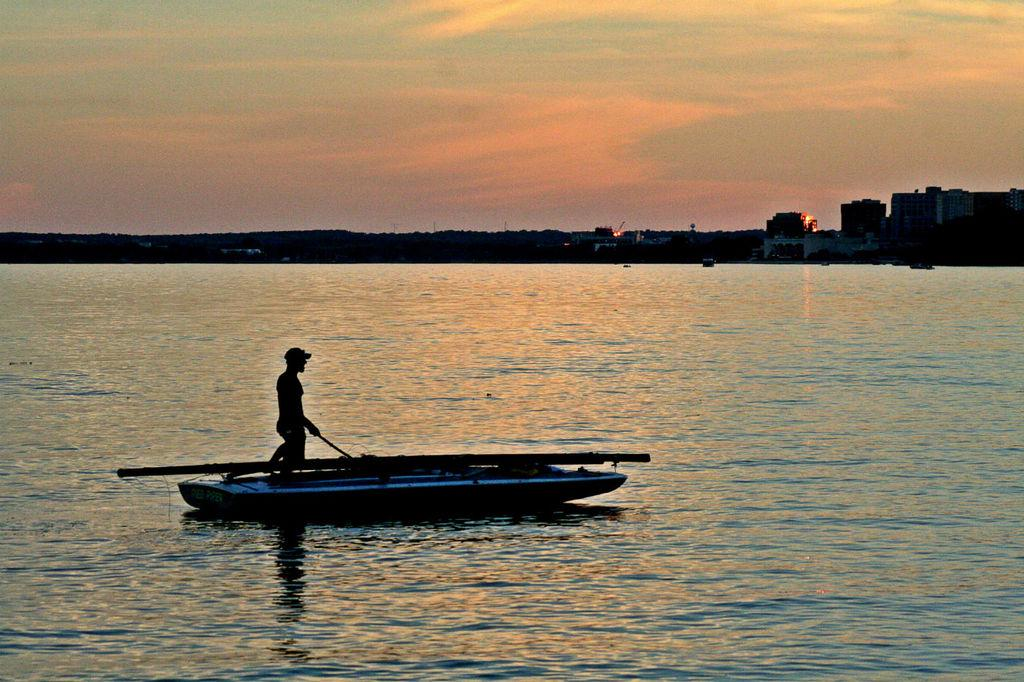What type of water body is present in the image? There is a river in the image. What is on the river in the image? There is a boat on the river. Who or what is in the boat? A person is standing in the boat. What can be seen in the background of the image? There are buildings and the sky visible in the background of the image. What type of guitar is the person playing in the boat? There is no guitar present in the image; the person is standing in the boat without any musical instruments. 